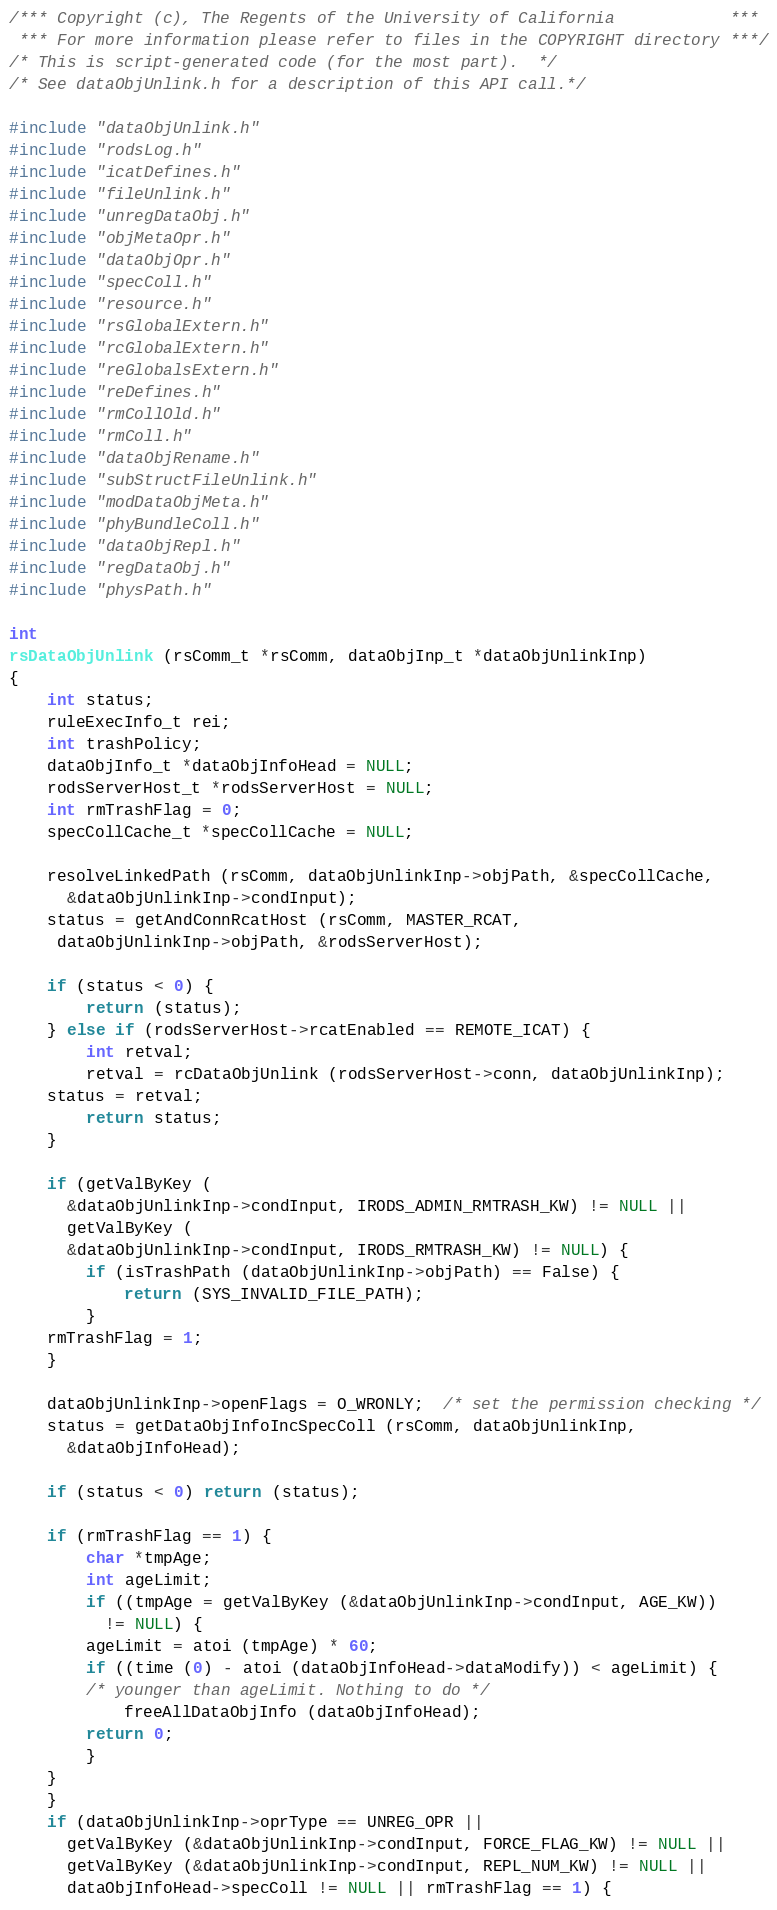Convert code to text. <code><loc_0><loc_0><loc_500><loc_500><_C_>/*** Copyright (c), The Regents of the University of California            ***
 *** For more information please refer to files in the COPYRIGHT directory ***/
/* This is script-generated code (for the most part).  */ 
/* See dataObjUnlink.h for a description of this API call.*/

#include "dataObjUnlink.h"
#include "rodsLog.h"
#include "icatDefines.h"
#include "fileUnlink.h"
#include "unregDataObj.h"
#include "objMetaOpr.h"
#include "dataObjOpr.h"
#include "specColl.h"
#include "resource.h"
#include "rsGlobalExtern.h"
#include "rcGlobalExtern.h"
#include "reGlobalsExtern.h"
#include "reDefines.h"
#include "rmCollOld.h"
#include "rmColl.h"
#include "dataObjRename.h"
#include "subStructFileUnlink.h"
#include "modDataObjMeta.h"
#include "phyBundleColl.h"
#include "dataObjRepl.h"
#include "regDataObj.h"
#include "physPath.h"

int
rsDataObjUnlink (rsComm_t *rsComm, dataObjInp_t *dataObjUnlinkInp)
{
    int status;
    ruleExecInfo_t rei;
    int trashPolicy;
    dataObjInfo_t *dataObjInfoHead = NULL;
    rodsServerHost_t *rodsServerHost = NULL;
    int rmTrashFlag = 0;
    specCollCache_t *specCollCache = NULL;

    resolveLinkedPath (rsComm, dataObjUnlinkInp->objPath, &specCollCache,
      &dataObjUnlinkInp->condInput);
    status = getAndConnRcatHost (rsComm, MASTER_RCAT,
     dataObjUnlinkInp->objPath, &rodsServerHost);

    if (status < 0) {
        return (status);
    } else if (rodsServerHost->rcatEnabled == REMOTE_ICAT) {
        int retval;
        retval = rcDataObjUnlink (rodsServerHost->conn, dataObjUnlinkInp);
	status = retval;
        return status;
    }

    if (getValByKey (
      &dataObjUnlinkInp->condInput, IRODS_ADMIN_RMTRASH_KW) != NULL ||
      getValByKey (
      &dataObjUnlinkInp->condInput, IRODS_RMTRASH_KW) != NULL) {
        if (isTrashPath (dataObjUnlinkInp->objPath) == False) {
            return (SYS_INVALID_FILE_PATH);
        }
	rmTrashFlag = 1;
    }

    dataObjUnlinkInp->openFlags = O_WRONLY;  /* set the permission checking */
    status = getDataObjInfoIncSpecColl (rsComm, dataObjUnlinkInp, 
      &dataObjInfoHead);

    if (status < 0) return (status);

    if (rmTrashFlag == 1) {
        char *tmpAge;
        int ageLimit;
        if ((tmpAge = getValByKey (&dataObjUnlinkInp->condInput, AGE_KW))
          != NULL) {
	    ageLimit = atoi (tmpAge) * 60;
	    if ((time (0) - atoi (dataObjInfoHead->dataModify)) < ageLimit) {
		/* younger than ageLimit. Nothing to do */
    		freeAllDataObjInfo (dataObjInfoHead);
		return 0;
	    }
	}
    }
    if (dataObjUnlinkInp->oprType == UNREG_OPR ||
      getValByKey (&dataObjUnlinkInp->condInput, FORCE_FLAG_KW) != NULL ||
      getValByKey (&dataObjUnlinkInp->condInput, REPL_NUM_KW) != NULL ||
      dataObjInfoHead->specColl != NULL || rmTrashFlag == 1) {</code> 